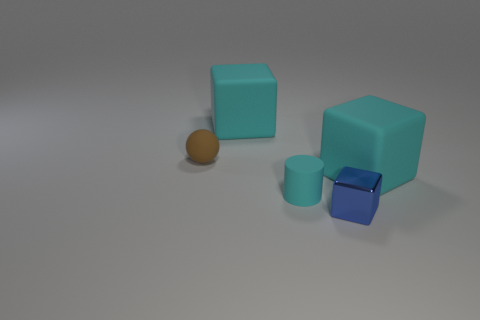What shape is the tiny object that is both on the left side of the metallic cube and right of the rubber ball?
Make the answer very short. Cylinder. What is the shape of the big rubber thing that is in front of the matte sphere?
Ensure brevity in your answer.  Cube. How many tiny things are both to the right of the tiny cyan cylinder and to the left of the tiny metallic block?
Ensure brevity in your answer.  0. Does the matte ball have the same size as the cube that is to the left of the blue block?
Your answer should be very brief. No. What size is the cyan thing that is behind the object on the left side of the large cyan object behind the tiny brown rubber ball?
Ensure brevity in your answer.  Large. There is a rubber cube right of the small cyan object; what is its size?
Your answer should be very brief. Large. What is the shape of the brown object that is made of the same material as the tiny cyan cylinder?
Your answer should be compact. Sphere. Are the small brown thing behind the tiny shiny cube and the small cylinder made of the same material?
Make the answer very short. Yes. How many other things are the same material as the brown ball?
Make the answer very short. 3. How many objects are cyan matte blocks to the left of the tiny cyan cylinder or cyan matte things that are behind the brown thing?
Make the answer very short. 1. 